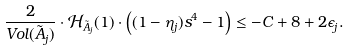Convert formula to latex. <formula><loc_0><loc_0><loc_500><loc_500>\frac { 2 } { V o l ( \tilde { A } _ { j } ) } \cdot \mathcal { H } _ { \tilde { A } _ { j } } ( 1 ) \cdot \left ( ( 1 - \eta _ { j } ) s ^ { 4 } - 1 \right ) \leq - C + 8 + 2 \epsilon _ { j } .</formula> 